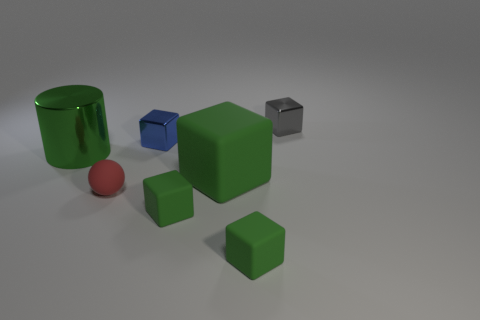Subtract all brown balls. How many green blocks are left? 3 Subtract all gray blocks. How many blocks are left? 4 Subtract all big blocks. How many blocks are left? 4 Subtract all red blocks. Subtract all purple balls. How many blocks are left? 5 Add 3 large gray metallic cylinders. How many objects exist? 10 Subtract all balls. How many objects are left? 6 Subtract all tiny brown shiny spheres. Subtract all red rubber spheres. How many objects are left? 6 Add 5 tiny green matte cubes. How many tiny green matte cubes are left? 7 Add 5 tiny green matte blocks. How many tiny green matte blocks exist? 7 Subtract 0 cyan cylinders. How many objects are left? 7 